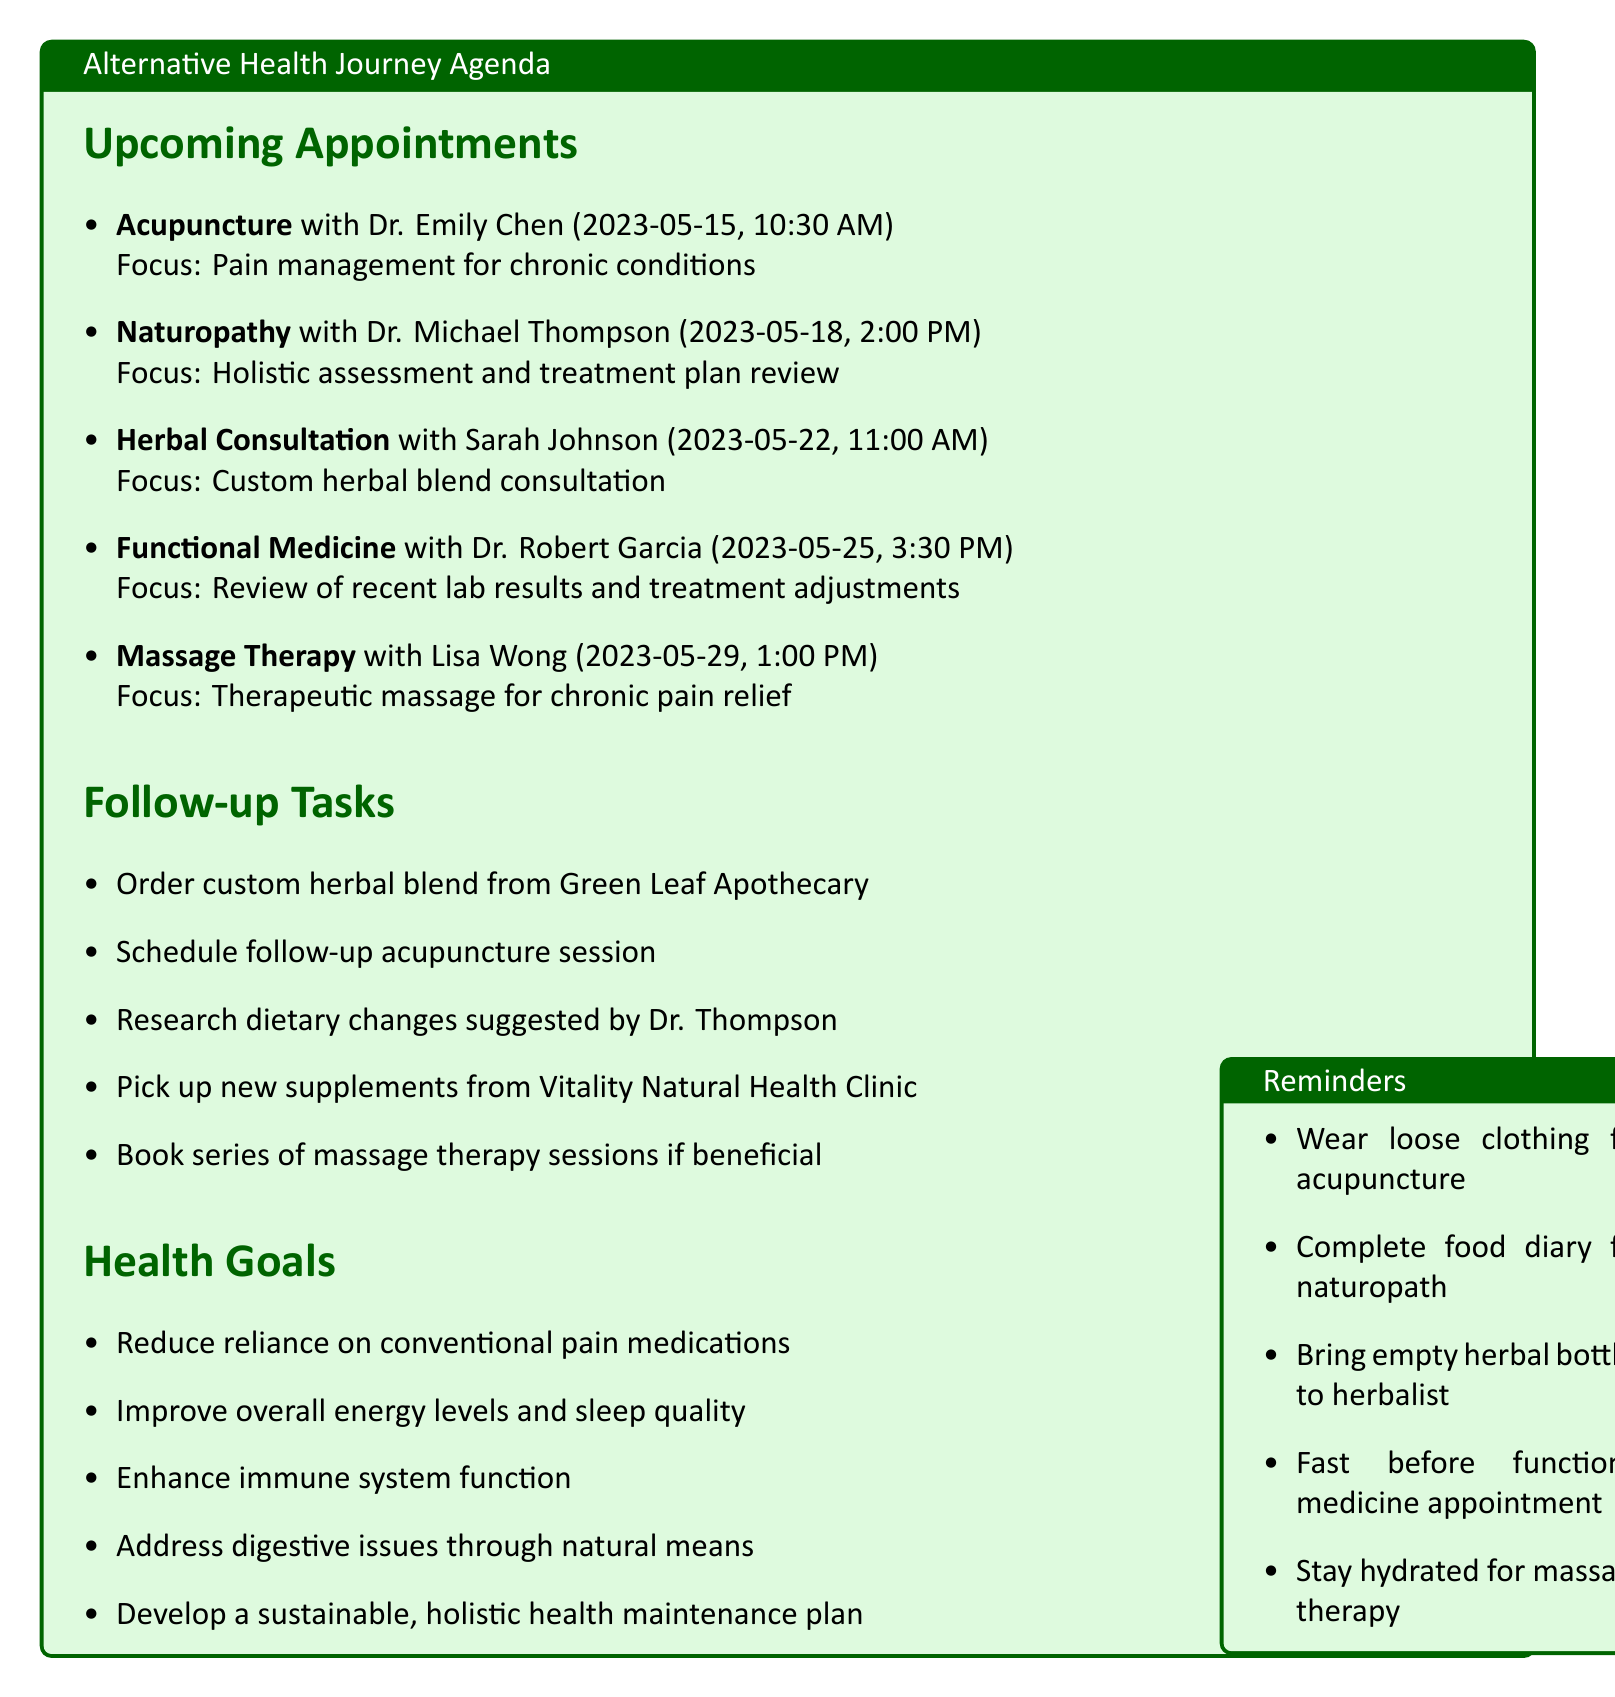What is the date of the acupuncture appointment? The date of the acupuncture appointment is listed in the "Upcoming Appointments" section.
Answer: 2023-05-15 Who is the herbalist practitioner? The herbalist practitioner is mentioned alongside the focus and details of the appointment.
Answer: Sarah Johnson What is the focus of the naturopath appointment? The focus of the naturopath appointment is specified in the document under "Upcoming Appointments."
Answer: Holistic assessment and treatment plan review How long is the massage therapy session? The duration of each appointment is noted next to the respective practitioner in the document.
Answer: 60 minutes What should you bring to the herbal consultation? The preparation notes indicate what to bring for each appointment.
Answer: Empty bottles of current herbal preparations Which clinic is associated with Dr. Robert Garcia? The clinic names are mentioned alongside each practitioner's details.
Answer: Integrative Wellness Center What task is related to the custom herbal blend? The follow-up tasks provide specific tasks to perform after appointments.
Answer: Order custom herbal blend from Green Leaf Apothecary How many minutes is the appointment with Dr. Michael Thompson? The duration for each appointment is included with the practitioner's details in the agenda.
Answer: 90 minutes 